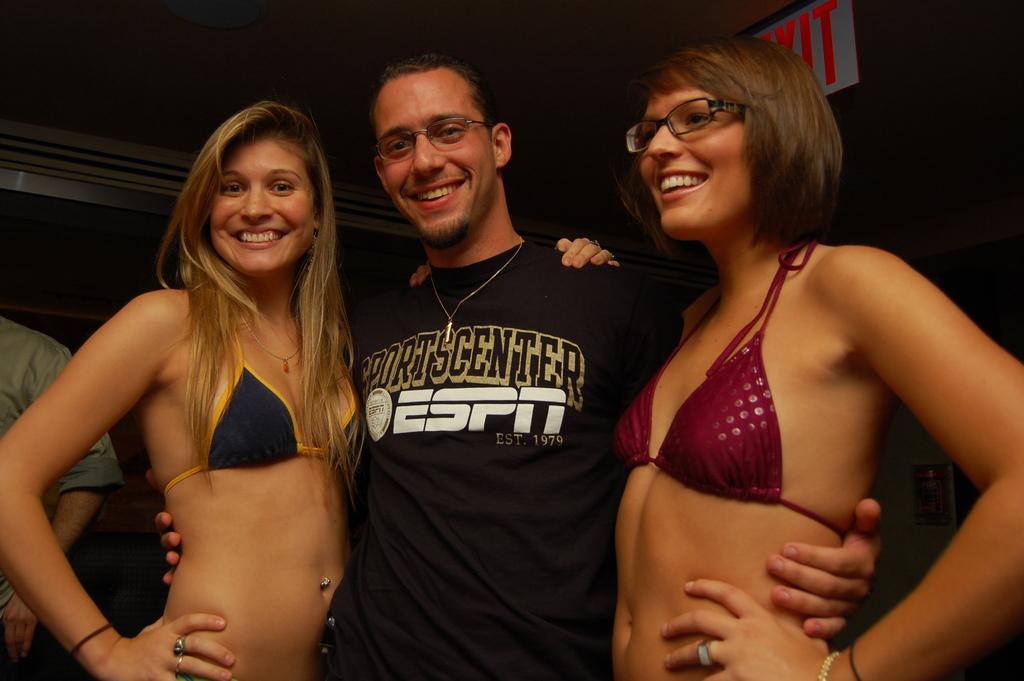Describe this image in one or two sentences. In front of the picture, we see a man and two women are standing. They are smiling and they are posing for the photo. The man and the woman on the right side are wearing the spectacles. On the left side, we see a man is standing. In the background, we see a wall. At the top, we see the exit board in white color. 